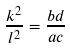Convert formula to latex. <formula><loc_0><loc_0><loc_500><loc_500>\frac { k ^ { 2 } } { l ^ { 2 } } = \frac { b d } { a c }</formula> 